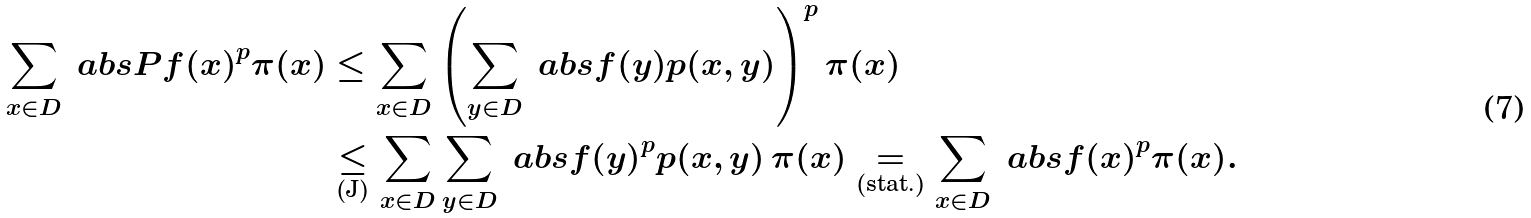<formula> <loc_0><loc_0><loc_500><loc_500>\sum _ { x \in D } \ a b s { P f ( x ) } ^ { p } \pi ( x ) & \leq \sum _ { x \in D } \left ( \sum _ { y \in D } \ a b s { f ( y ) } p ( x , y ) \right ) ^ { p } \pi ( x ) \\ & \underset { ( \text {J} ) } { \leq } \sum _ { x \in D } \sum _ { y \in D } \ a b s { f ( y ) } ^ { p } p ( x , y ) \, \pi ( x ) \underset { ( \text {stat.} ) } { = } \sum _ { x \in D } \ a b s { f ( x ) } ^ { p } \pi ( x ) .</formula> 